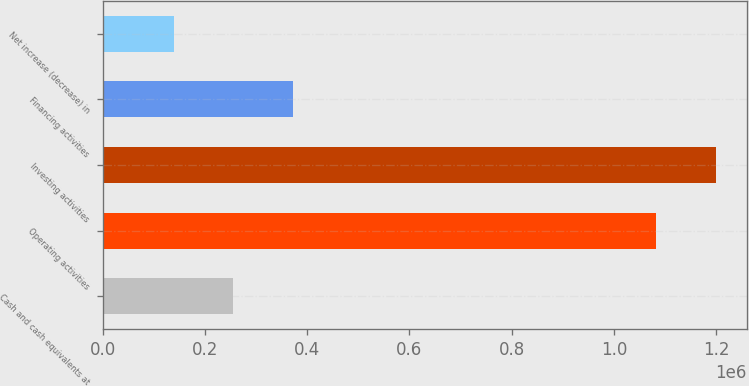<chart> <loc_0><loc_0><loc_500><loc_500><bar_chart><fcel>Cash and cash equivalents at<fcel>Operating activities<fcel>Investing activities<fcel>Financing activities<fcel>Net increase (decrease) in<nl><fcel>255687<fcel>1.08259e+06<fcel>1.19966e+06<fcel>372757<fcel>138618<nl></chart> 